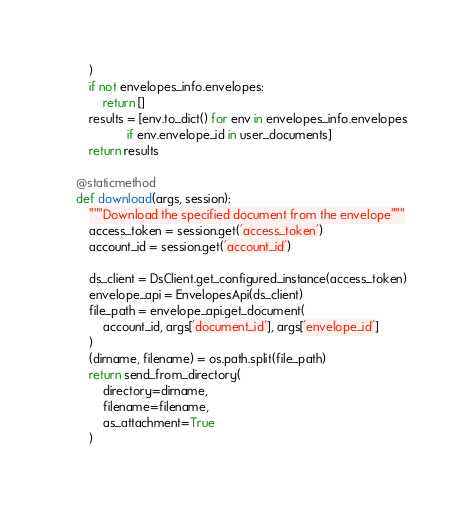Convert code to text. <code><loc_0><loc_0><loc_500><loc_500><_Python_>        )
        if not envelopes_info.envelopes:
            return []
        results = [env.to_dict() for env in envelopes_info.envelopes
                   if env.envelope_id in user_documents]
        return results

    @staticmethod
    def download(args, session):
        """Download the specified document from the envelope"""
        access_token = session.get('access_token')
        account_id = session.get('account_id')

        ds_client = DsClient.get_configured_instance(access_token)
        envelope_api = EnvelopesApi(ds_client)
        file_path = envelope_api.get_document(
            account_id, args['document_id'], args['envelope_id']
        )
        (dirname, filename) = os.path.split(file_path)
        return send_from_directory(
            directory=dirname,
            filename=filename,
            as_attachment=True
        )
</code> 